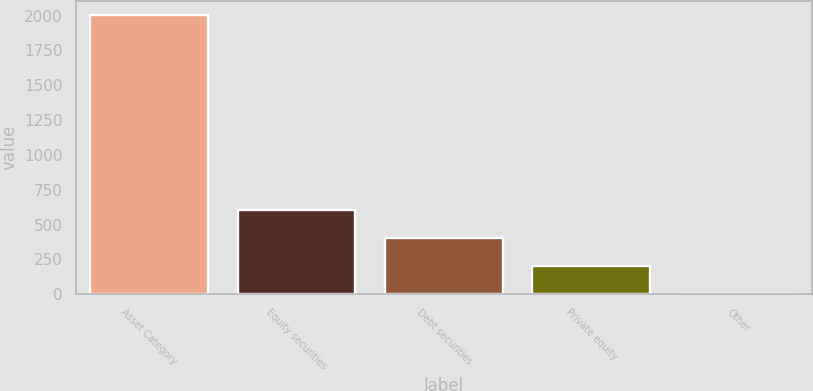Convert chart to OTSL. <chart><loc_0><loc_0><loc_500><loc_500><bar_chart><fcel>Asset Category<fcel>Equity securities<fcel>Debt securities<fcel>Private equity<fcel>Other<nl><fcel>2003<fcel>601.6<fcel>401.4<fcel>201.2<fcel>1<nl></chart> 